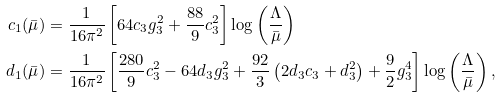<formula> <loc_0><loc_0><loc_500><loc_500>c _ { 1 } ( \bar { \mu } ) & = \frac { 1 } { 1 6 \pi ^ { 2 } } \left [ 6 4 c _ { 3 } g _ { 3 } ^ { 2 } + \frac { 8 8 } { 9 } c _ { 3 } ^ { 2 } \right ] \log \left ( \frac { \Lambda } { \bar { \mu } } \right ) \\ d _ { 1 } ( \bar { \mu } ) & = \frac { 1 } { 1 6 \pi ^ { 2 } } \left [ \frac { 2 8 0 } { 9 } c _ { 3 } ^ { 2 } - 6 4 d _ { 3 } g _ { 3 } ^ { 2 } + \frac { 9 2 } { 3 } \left ( 2 d _ { 3 } c _ { 3 } + d _ { 3 } ^ { 2 } \right ) + \frac { 9 } { 2 } g _ { 3 } ^ { 4 } \right ] \log \left ( \frac { \Lambda } { \bar { \mu } } \right ) ,</formula> 